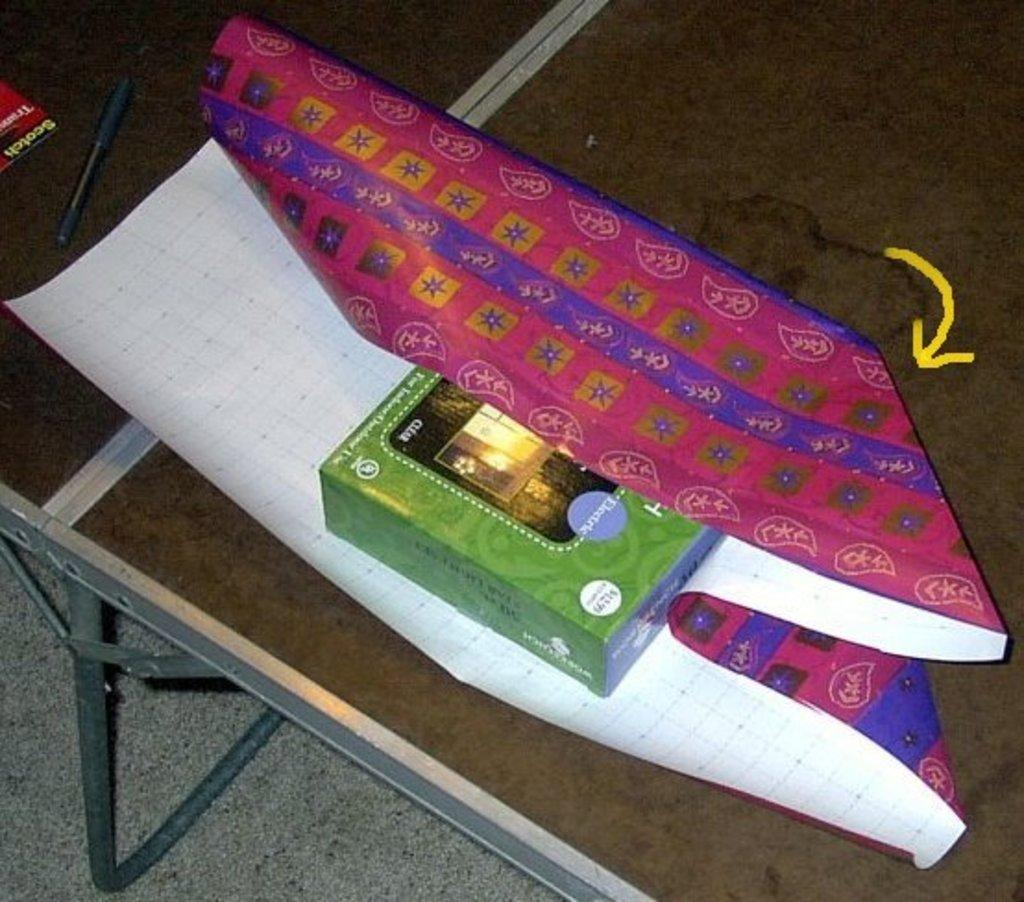What piece of furniture is present in the image? There is a table in the image. What is placed on the table? There is a chart, a box, a book, and a pen on the table. Can you describe the floor in the image? The floor is visible at the bottom of the image. What type of heat can be felt coming from the chart in the image? There is no indication of heat in the image, and the chart is not described as producing any heat. 